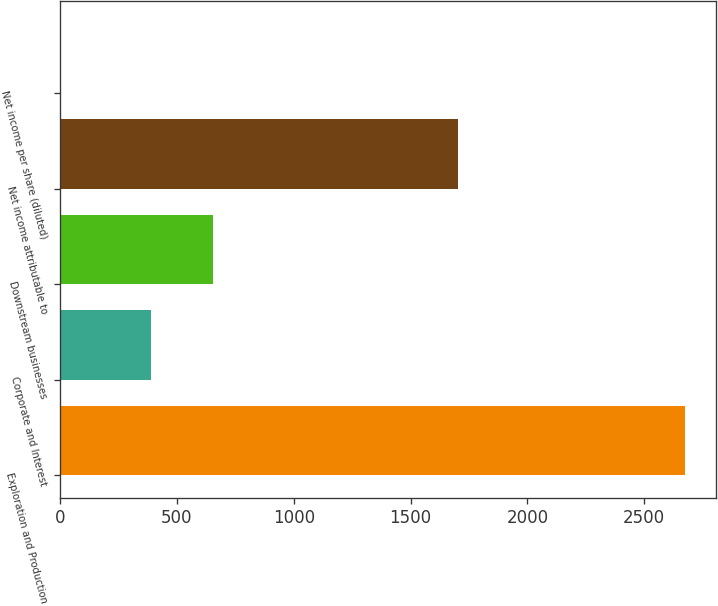<chart> <loc_0><loc_0><loc_500><loc_500><bar_chart><fcel>Exploration and Production<fcel>Corporate and Interest<fcel>Downstream businesses<fcel>Net income attributable to<fcel>Net income per share (diluted)<nl><fcel>2675<fcel>388<fcel>655<fcel>1703<fcel>5.01<nl></chart> 